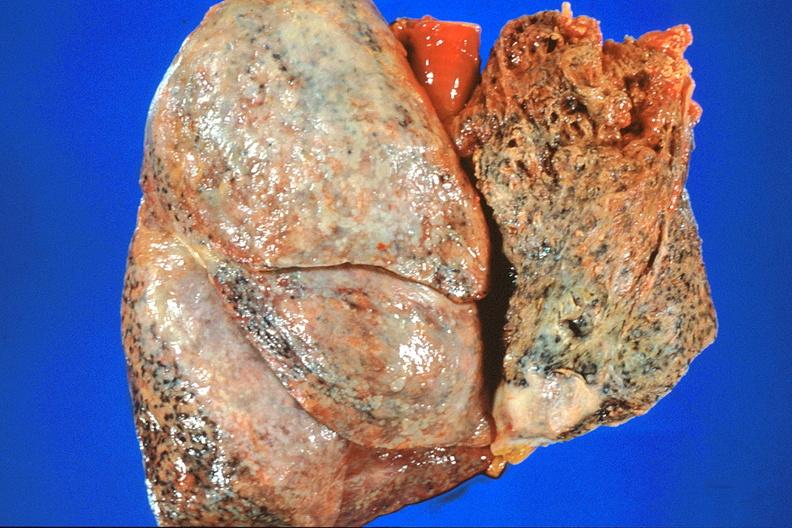where is this?
Answer the question using a single word or phrase. Lung 